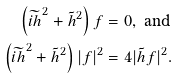<formula> <loc_0><loc_0><loc_500><loc_500>\left ( \widetilde { i h } ^ { 2 } + \tilde { h } ^ { 2 } \right ) f & = 0 , \text { and} \\ \left ( \widetilde { i h } ^ { 2 } + \tilde { h } ^ { 2 } \right ) | f | ^ { 2 } & = 4 | \tilde { h } f | ^ { 2 } .</formula> 